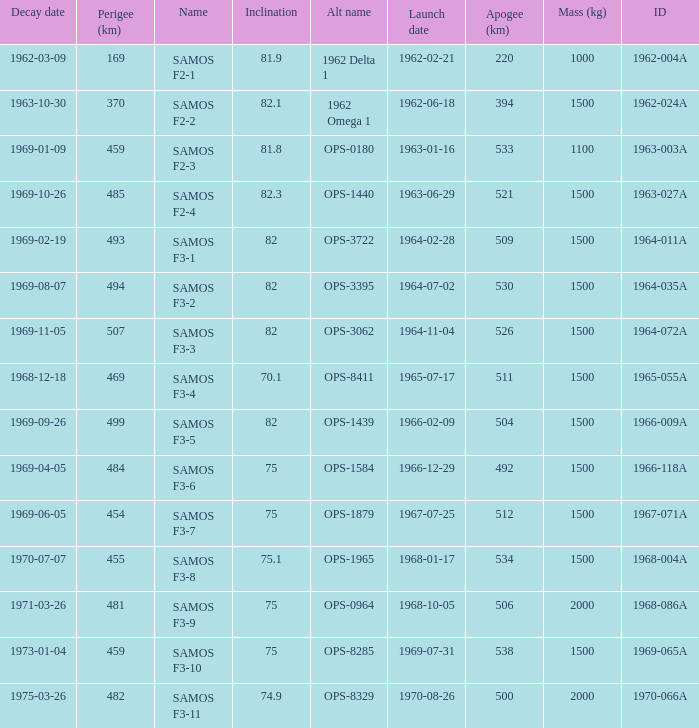How many alt names does 1964-011a have? 1.0. Could you parse the entire table? {'header': ['Decay date', 'Perigee (km)', 'Name', 'Inclination', 'Alt name', 'Launch date', 'Apogee (km)', 'Mass (kg)', 'ID'], 'rows': [['1962-03-09', '169', 'SAMOS F2-1', '81.9', '1962 Delta 1', '1962-02-21', '220', '1000', '1962-004A'], ['1963-10-30', '370', 'SAMOS F2-2', '82.1', '1962 Omega 1', '1962-06-18', '394', '1500', '1962-024A'], ['1969-01-09', '459', 'SAMOS F2-3', '81.8', 'OPS-0180', '1963-01-16', '533', '1100', '1963-003A'], ['1969-10-26', '485', 'SAMOS F2-4', '82.3', 'OPS-1440', '1963-06-29', '521', '1500', '1963-027A'], ['1969-02-19', '493', 'SAMOS F3-1', '82', 'OPS-3722', '1964-02-28', '509', '1500', '1964-011A'], ['1969-08-07', '494', 'SAMOS F3-2', '82', 'OPS-3395', '1964-07-02', '530', '1500', '1964-035A'], ['1969-11-05', '507', 'SAMOS F3-3', '82', 'OPS-3062', '1964-11-04', '526', '1500', '1964-072A'], ['1968-12-18', '469', 'SAMOS F3-4', '70.1', 'OPS-8411', '1965-07-17', '511', '1500', '1965-055A'], ['1969-09-26', '499', 'SAMOS F3-5', '82', 'OPS-1439', '1966-02-09', '504', '1500', '1966-009A'], ['1969-04-05', '484', 'SAMOS F3-6', '75', 'OPS-1584', '1966-12-29', '492', '1500', '1966-118A'], ['1969-06-05', '454', 'SAMOS F3-7', '75', 'OPS-1879', '1967-07-25', '512', '1500', '1967-071A'], ['1970-07-07', '455', 'SAMOS F3-8', '75.1', 'OPS-1965', '1968-01-17', '534', '1500', '1968-004A'], ['1971-03-26', '481', 'SAMOS F3-9', '75', 'OPS-0964', '1968-10-05', '506', '2000', '1968-086A'], ['1973-01-04', '459', 'SAMOS F3-10', '75', 'OPS-8285', '1969-07-31', '538', '1500', '1969-065A'], ['1975-03-26', '482', 'SAMOS F3-11', '74.9', 'OPS-8329', '1970-08-26', '500', '2000', '1970-066A']]} 